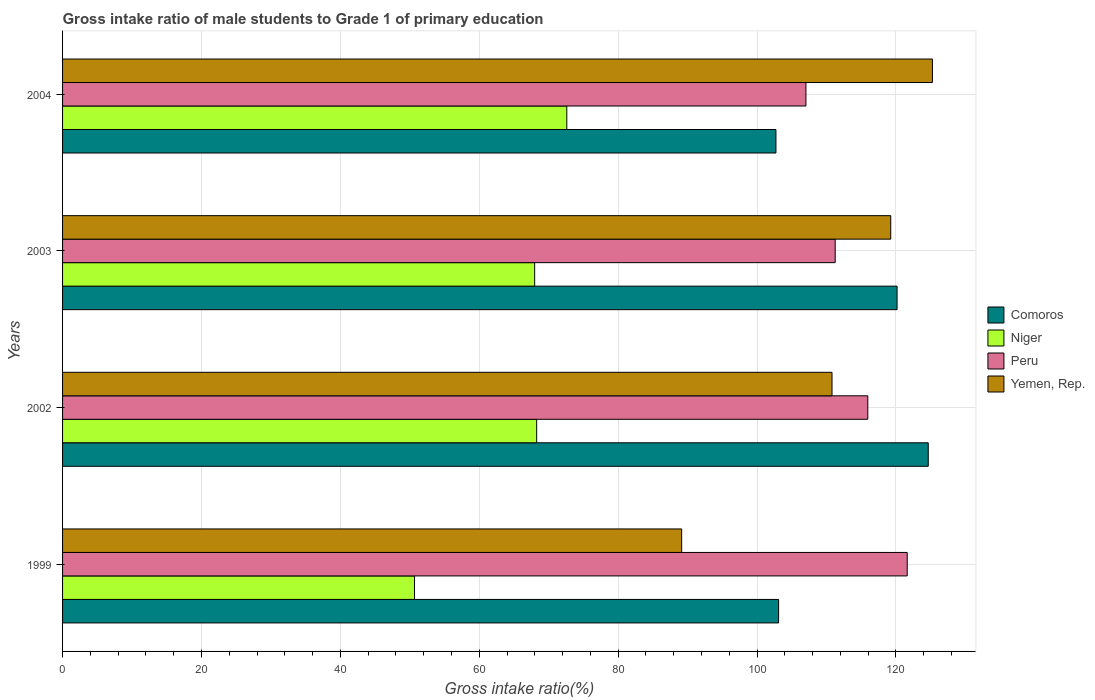How many different coloured bars are there?
Provide a short and direct response. 4. How many groups of bars are there?
Your answer should be compact. 4. Are the number of bars per tick equal to the number of legend labels?
Keep it short and to the point. Yes. Are the number of bars on each tick of the Y-axis equal?
Offer a very short reply. Yes. How many bars are there on the 4th tick from the bottom?
Keep it short and to the point. 4. What is the label of the 1st group of bars from the top?
Make the answer very short. 2004. In how many cases, is the number of bars for a given year not equal to the number of legend labels?
Your response must be concise. 0. What is the gross intake ratio in Comoros in 2002?
Provide a short and direct response. 124.66. Across all years, what is the maximum gross intake ratio in Peru?
Offer a very short reply. 121.63. Across all years, what is the minimum gross intake ratio in Peru?
Provide a succinct answer. 107.05. In which year was the gross intake ratio in Yemen, Rep. minimum?
Make the answer very short. 1999. What is the total gross intake ratio in Yemen, Rep. in the graph?
Your response must be concise. 444.47. What is the difference between the gross intake ratio in Yemen, Rep. in 1999 and that in 2004?
Provide a succinct answer. -36.11. What is the difference between the gross intake ratio in Niger in 1999 and the gross intake ratio in Yemen, Rep. in 2002?
Provide a succinct answer. -60.12. What is the average gross intake ratio in Niger per year?
Make the answer very short. 64.89. In the year 2003, what is the difference between the gross intake ratio in Yemen, Rep. and gross intake ratio in Comoros?
Offer a terse response. -0.91. What is the ratio of the gross intake ratio in Yemen, Rep. in 2003 to that in 2004?
Provide a succinct answer. 0.95. Is the gross intake ratio in Comoros in 2002 less than that in 2003?
Ensure brevity in your answer.  No. What is the difference between the highest and the second highest gross intake ratio in Peru?
Ensure brevity in your answer.  5.68. What is the difference between the highest and the lowest gross intake ratio in Yemen, Rep.?
Offer a very short reply. 36.11. Is the sum of the gross intake ratio in Comoros in 2003 and 2004 greater than the maximum gross intake ratio in Yemen, Rep. across all years?
Offer a terse response. Yes. What does the 2nd bar from the top in 2002 represents?
Your answer should be compact. Peru. What does the 2nd bar from the bottom in 1999 represents?
Give a very brief answer. Niger. Are all the bars in the graph horizontal?
Provide a succinct answer. Yes. How many years are there in the graph?
Keep it short and to the point. 4. What is the difference between two consecutive major ticks on the X-axis?
Keep it short and to the point. 20. Does the graph contain grids?
Ensure brevity in your answer.  Yes. What is the title of the graph?
Keep it short and to the point. Gross intake ratio of male students to Grade 1 of primary education. What is the label or title of the X-axis?
Keep it short and to the point. Gross intake ratio(%). What is the label or title of the Y-axis?
Your answer should be very brief. Years. What is the Gross intake ratio(%) in Comoros in 1999?
Your answer should be compact. 103.11. What is the Gross intake ratio(%) of Niger in 1999?
Make the answer very short. 50.68. What is the Gross intake ratio(%) in Peru in 1999?
Make the answer very short. 121.63. What is the Gross intake ratio(%) of Yemen, Rep. in 1999?
Keep it short and to the point. 89.15. What is the Gross intake ratio(%) in Comoros in 2002?
Give a very brief answer. 124.66. What is the Gross intake ratio(%) in Niger in 2002?
Make the answer very short. 68.27. What is the Gross intake ratio(%) of Peru in 2002?
Give a very brief answer. 115.95. What is the Gross intake ratio(%) in Yemen, Rep. in 2002?
Your answer should be compact. 110.8. What is the Gross intake ratio(%) of Comoros in 2003?
Offer a terse response. 120.17. What is the Gross intake ratio(%) in Niger in 2003?
Provide a succinct answer. 67.98. What is the Gross intake ratio(%) in Peru in 2003?
Your answer should be compact. 111.26. What is the Gross intake ratio(%) of Yemen, Rep. in 2003?
Keep it short and to the point. 119.26. What is the Gross intake ratio(%) of Comoros in 2004?
Offer a very short reply. 102.73. What is the Gross intake ratio(%) in Niger in 2004?
Give a very brief answer. 72.61. What is the Gross intake ratio(%) in Peru in 2004?
Give a very brief answer. 107.05. What is the Gross intake ratio(%) of Yemen, Rep. in 2004?
Provide a succinct answer. 125.26. Across all years, what is the maximum Gross intake ratio(%) of Comoros?
Offer a terse response. 124.66. Across all years, what is the maximum Gross intake ratio(%) of Niger?
Your answer should be compact. 72.61. Across all years, what is the maximum Gross intake ratio(%) of Peru?
Keep it short and to the point. 121.63. Across all years, what is the maximum Gross intake ratio(%) in Yemen, Rep.?
Offer a terse response. 125.26. Across all years, what is the minimum Gross intake ratio(%) in Comoros?
Provide a short and direct response. 102.73. Across all years, what is the minimum Gross intake ratio(%) of Niger?
Make the answer very short. 50.68. Across all years, what is the minimum Gross intake ratio(%) of Peru?
Provide a short and direct response. 107.05. Across all years, what is the minimum Gross intake ratio(%) of Yemen, Rep.?
Your answer should be compact. 89.15. What is the total Gross intake ratio(%) of Comoros in the graph?
Your response must be concise. 450.67. What is the total Gross intake ratio(%) in Niger in the graph?
Keep it short and to the point. 259.54. What is the total Gross intake ratio(%) of Peru in the graph?
Your answer should be very brief. 455.89. What is the total Gross intake ratio(%) in Yemen, Rep. in the graph?
Provide a succinct answer. 444.47. What is the difference between the Gross intake ratio(%) of Comoros in 1999 and that in 2002?
Ensure brevity in your answer.  -21.55. What is the difference between the Gross intake ratio(%) of Niger in 1999 and that in 2002?
Your answer should be compact. -17.59. What is the difference between the Gross intake ratio(%) of Peru in 1999 and that in 2002?
Provide a succinct answer. 5.68. What is the difference between the Gross intake ratio(%) in Yemen, Rep. in 1999 and that in 2002?
Provide a short and direct response. -21.65. What is the difference between the Gross intake ratio(%) of Comoros in 1999 and that in 2003?
Ensure brevity in your answer.  -17.06. What is the difference between the Gross intake ratio(%) of Niger in 1999 and that in 2003?
Your answer should be very brief. -17.3. What is the difference between the Gross intake ratio(%) in Peru in 1999 and that in 2003?
Ensure brevity in your answer.  10.37. What is the difference between the Gross intake ratio(%) in Yemen, Rep. in 1999 and that in 2003?
Your answer should be compact. -30.1. What is the difference between the Gross intake ratio(%) in Comoros in 1999 and that in 2004?
Make the answer very short. 0.38. What is the difference between the Gross intake ratio(%) in Niger in 1999 and that in 2004?
Keep it short and to the point. -21.93. What is the difference between the Gross intake ratio(%) in Peru in 1999 and that in 2004?
Your answer should be compact. 14.58. What is the difference between the Gross intake ratio(%) in Yemen, Rep. in 1999 and that in 2004?
Make the answer very short. -36.11. What is the difference between the Gross intake ratio(%) in Comoros in 2002 and that in 2003?
Your response must be concise. 4.49. What is the difference between the Gross intake ratio(%) in Niger in 2002 and that in 2003?
Provide a succinct answer. 0.29. What is the difference between the Gross intake ratio(%) in Peru in 2002 and that in 2003?
Provide a short and direct response. 4.69. What is the difference between the Gross intake ratio(%) of Yemen, Rep. in 2002 and that in 2003?
Your response must be concise. -8.46. What is the difference between the Gross intake ratio(%) of Comoros in 2002 and that in 2004?
Keep it short and to the point. 21.93. What is the difference between the Gross intake ratio(%) of Niger in 2002 and that in 2004?
Your response must be concise. -4.34. What is the difference between the Gross intake ratio(%) in Peru in 2002 and that in 2004?
Make the answer very short. 8.91. What is the difference between the Gross intake ratio(%) in Yemen, Rep. in 2002 and that in 2004?
Your answer should be compact. -14.46. What is the difference between the Gross intake ratio(%) in Comoros in 2003 and that in 2004?
Offer a very short reply. 17.45. What is the difference between the Gross intake ratio(%) in Niger in 2003 and that in 2004?
Give a very brief answer. -4.63. What is the difference between the Gross intake ratio(%) in Peru in 2003 and that in 2004?
Make the answer very short. 4.21. What is the difference between the Gross intake ratio(%) of Yemen, Rep. in 2003 and that in 2004?
Ensure brevity in your answer.  -6. What is the difference between the Gross intake ratio(%) in Comoros in 1999 and the Gross intake ratio(%) in Niger in 2002?
Provide a succinct answer. 34.84. What is the difference between the Gross intake ratio(%) of Comoros in 1999 and the Gross intake ratio(%) of Peru in 2002?
Your response must be concise. -12.84. What is the difference between the Gross intake ratio(%) of Comoros in 1999 and the Gross intake ratio(%) of Yemen, Rep. in 2002?
Provide a short and direct response. -7.69. What is the difference between the Gross intake ratio(%) in Niger in 1999 and the Gross intake ratio(%) in Peru in 2002?
Provide a short and direct response. -65.28. What is the difference between the Gross intake ratio(%) of Niger in 1999 and the Gross intake ratio(%) of Yemen, Rep. in 2002?
Your answer should be very brief. -60.12. What is the difference between the Gross intake ratio(%) in Peru in 1999 and the Gross intake ratio(%) in Yemen, Rep. in 2002?
Make the answer very short. 10.83. What is the difference between the Gross intake ratio(%) in Comoros in 1999 and the Gross intake ratio(%) in Niger in 2003?
Your response must be concise. 35.13. What is the difference between the Gross intake ratio(%) in Comoros in 1999 and the Gross intake ratio(%) in Peru in 2003?
Offer a very short reply. -8.15. What is the difference between the Gross intake ratio(%) of Comoros in 1999 and the Gross intake ratio(%) of Yemen, Rep. in 2003?
Give a very brief answer. -16.15. What is the difference between the Gross intake ratio(%) in Niger in 1999 and the Gross intake ratio(%) in Peru in 2003?
Your response must be concise. -60.58. What is the difference between the Gross intake ratio(%) in Niger in 1999 and the Gross intake ratio(%) in Yemen, Rep. in 2003?
Your response must be concise. -68.58. What is the difference between the Gross intake ratio(%) in Peru in 1999 and the Gross intake ratio(%) in Yemen, Rep. in 2003?
Offer a terse response. 2.37. What is the difference between the Gross intake ratio(%) in Comoros in 1999 and the Gross intake ratio(%) in Niger in 2004?
Provide a succinct answer. 30.5. What is the difference between the Gross intake ratio(%) in Comoros in 1999 and the Gross intake ratio(%) in Peru in 2004?
Make the answer very short. -3.94. What is the difference between the Gross intake ratio(%) in Comoros in 1999 and the Gross intake ratio(%) in Yemen, Rep. in 2004?
Offer a terse response. -22.15. What is the difference between the Gross intake ratio(%) of Niger in 1999 and the Gross intake ratio(%) of Peru in 2004?
Give a very brief answer. -56.37. What is the difference between the Gross intake ratio(%) of Niger in 1999 and the Gross intake ratio(%) of Yemen, Rep. in 2004?
Provide a succinct answer. -74.58. What is the difference between the Gross intake ratio(%) of Peru in 1999 and the Gross intake ratio(%) of Yemen, Rep. in 2004?
Your response must be concise. -3.63. What is the difference between the Gross intake ratio(%) of Comoros in 2002 and the Gross intake ratio(%) of Niger in 2003?
Your response must be concise. 56.68. What is the difference between the Gross intake ratio(%) in Comoros in 2002 and the Gross intake ratio(%) in Peru in 2003?
Keep it short and to the point. 13.4. What is the difference between the Gross intake ratio(%) in Comoros in 2002 and the Gross intake ratio(%) in Yemen, Rep. in 2003?
Your answer should be compact. 5.4. What is the difference between the Gross intake ratio(%) in Niger in 2002 and the Gross intake ratio(%) in Peru in 2003?
Offer a terse response. -42.99. What is the difference between the Gross intake ratio(%) of Niger in 2002 and the Gross intake ratio(%) of Yemen, Rep. in 2003?
Your answer should be compact. -50.99. What is the difference between the Gross intake ratio(%) in Peru in 2002 and the Gross intake ratio(%) in Yemen, Rep. in 2003?
Keep it short and to the point. -3.3. What is the difference between the Gross intake ratio(%) of Comoros in 2002 and the Gross intake ratio(%) of Niger in 2004?
Offer a very short reply. 52.05. What is the difference between the Gross intake ratio(%) in Comoros in 2002 and the Gross intake ratio(%) in Peru in 2004?
Make the answer very short. 17.61. What is the difference between the Gross intake ratio(%) in Comoros in 2002 and the Gross intake ratio(%) in Yemen, Rep. in 2004?
Make the answer very short. -0.6. What is the difference between the Gross intake ratio(%) of Niger in 2002 and the Gross intake ratio(%) of Peru in 2004?
Give a very brief answer. -38.78. What is the difference between the Gross intake ratio(%) in Niger in 2002 and the Gross intake ratio(%) in Yemen, Rep. in 2004?
Your response must be concise. -56.99. What is the difference between the Gross intake ratio(%) of Peru in 2002 and the Gross intake ratio(%) of Yemen, Rep. in 2004?
Your answer should be compact. -9.31. What is the difference between the Gross intake ratio(%) of Comoros in 2003 and the Gross intake ratio(%) of Niger in 2004?
Offer a terse response. 47.56. What is the difference between the Gross intake ratio(%) in Comoros in 2003 and the Gross intake ratio(%) in Peru in 2004?
Keep it short and to the point. 13.12. What is the difference between the Gross intake ratio(%) in Comoros in 2003 and the Gross intake ratio(%) in Yemen, Rep. in 2004?
Your answer should be very brief. -5.09. What is the difference between the Gross intake ratio(%) in Niger in 2003 and the Gross intake ratio(%) in Peru in 2004?
Provide a short and direct response. -39.07. What is the difference between the Gross intake ratio(%) in Niger in 2003 and the Gross intake ratio(%) in Yemen, Rep. in 2004?
Make the answer very short. -57.28. What is the difference between the Gross intake ratio(%) of Peru in 2003 and the Gross intake ratio(%) of Yemen, Rep. in 2004?
Keep it short and to the point. -14. What is the average Gross intake ratio(%) of Comoros per year?
Your response must be concise. 112.67. What is the average Gross intake ratio(%) in Niger per year?
Your answer should be compact. 64.89. What is the average Gross intake ratio(%) in Peru per year?
Your answer should be very brief. 113.97. What is the average Gross intake ratio(%) in Yemen, Rep. per year?
Ensure brevity in your answer.  111.12. In the year 1999, what is the difference between the Gross intake ratio(%) of Comoros and Gross intake ratio(%) of Niger?
Offer a very short reply. 52.43. In the year 1999, what is the difference between the Gross intake ratio(%) in Comoros and Gross intake ratio(%) in Peru?
Your answer should be compact. -18.52. In the year 1999, what is the difference between the Gross intake ratio(%) in Comoros and Gross intake ratio(%) in Yemen, Rep.?
Offer a terse response. 13.96. In the year 1999, what is the difference between the Gross intake ratio(%) in Niger and Gross intake ratio(%) in Peru?
Your answer should be very brief. -70.95. In the year 1999, what is the difference between the Gross intake ratio(%) of Niger and Gross intake ratio(%) of Yemen, Rep.?
Offer a terse response. -38.48. In the year 1999, what is the difference between the Gross intake ratio(%) of Peru and Gross intake ratio(%) of Yemen, Rep.?
Your response must be concise. 32.48. In the year 2002, what is the difference between the Gross intake ratio(%) of Comoros and Gross intake ratio(%) of Niger?
Your answer should be very brief. 56.39. In the year 2002, what is the difference between the Gross intake ratio(%) of Comoros and Gross intake ratio(%) of Peru?
Your response must be concise. 8.71. In the year 2002, what is the difference between the Gross intake ratio(%) in Comoros and Gross intake ratio(%) in Yemen, Rep.?
Provide a short and direct response. 13.86. In the year 2002, what is the difference between the Gross intake ratio(%) of Niger and Gross intake ratio(%) of Peru?
Provide a succinct answer. -47.68. In the year 2002, what is the difference between the Gross intake ratio(%) of Niger and Gross intake ratio(%) of Yemen, Rep.?
Ensure brevity in your answer.  -42.53. In the year 2002, what is the difference between the Gross intake ratio(%) of Peru and Gross intake ratio(%) of Yemen, Rep.?
Give a very brief answer. 5.15. In the year 2003, what is the difference between the Gross intake ratio(%) in Comoros and Gross intake ratio(%) in Niger?
Ensure brevity in your answer.  52.19. In the year 2003, what is the difference between the Gross intake ratio(%) in Comoros and Gross intake ratio(%) in Peru?
Keep it short and to the point. 8.91. In the year 2003, what is the difference between the Gross intake ratio(%) of Comoros and Gross intake ratio(%) of Yemen, Rep.?
Your response must be concise. 0.91. In the year 2003, what is the difference between the Gross intake ratio(%) of Niger and Gross intake ratio(%) of Peru?
Make the answer very short. -43.28. In the year 2003, what is the difference between the Gross intake ratio(%) in Niger and Gross intake ratio(%) in Yemen, Rep.?
Give a very brief answer. -51.28. In the year 2003, what is the difference between the Gross intake ratio(%) of Peru and Gross intake ratio(%) of Yemen, Rep.?
Ensure brevity in your answer.  -8. In the year 2004, what is the difference between the Gross intake ratio(%) in Comoros and Gross intake ratio(%) in Niger?
Your response must be concise. 30.12. In the year 2004, what is the difference between the Gross intake ratio(%) in Comoros and Gross intake ratio(%) in Peru?
Offer a very short reply. -4.32. In the year 2004, what is the difference between the Gross intake ratio(%) of Comoros and Gross intake ratio(%) of Yemen, Rep.?
Offer a very short reply. -22.53. In the year 2004, what is the difference between the Gross intake ratio(%) of Niger and Gross intake ratio(%) of Peru?
Your response must be concise. -34.44. In the year 2004, what is the difference between the Gross intake ratio(%) in Niger and Gross intake ratio(%) in Yemen, Rep.?
Provide a succinct answer. -52.65. In the year 2004, what is the difference between the Gross intake ratio(%) in Peru and Gross intake ratio(%) in Yemen, Rep.?
Ensure brevity in your answer.  -18.21. What is the ratio of the Gross intake ratio(%) in Comoros in 1999 to that in 2002?
Provide a succinct answer. 0.83. What is the ratio of the Gross intake ratio(%) of Niger in 1999 to that in 2002?
Ensure brevity in your answer.  0.74. What is the ratio of the Gross intake ratio(%) in Peru in 1999 to that in 2002?
Make the answer very short. 1.05. What is the ratio of the Gross intake ratio(%) of Yemen, Rep. in 1999 to that in 2002?
Ensure brevity in your answer.  0.8. What is the ratio of the Gross intake ratio(%) in Comoros in 1999 to that in 2003?
Ensure brevity in your answer.  0.86. What is the ratio of the Gross intake ratio(%) of Niger in 1999 to that in 2003?
Offer a very short reply. 0.75. What is the ratio of the Gross intake ratio(%) of Peru in 1999 to that in 2003?
Keep it short and to the point. 1.09. What is the ratio of the Gross intake ratio(%) of Yemen, Rep. in 1999 to that in 2003?
Give a very brief answer. 0.75. What is the ratio of the Gross intake ratio(%) in Niger in 1999 to that in 2004?
Provide a short and direct response. 0.7. What is the ratio of the Gross intake ratio(%) in Peru in 1999 to that in 2004?
Keep it short and to the point. 1.14. What is the ratio of the Gross intake ratio(%) in Yemen, Rep. in 1999 to that in 2004?
Your answer should be compact. 0.71. What is the ratio of the Gross intake ratio(%) in Comoros in 2002 to that in 2003?
Provide a short and direct response. 1.04. What is the ratio of the Gross intake ratio(%) in Peru in 2002 to that in 2003?
Give a very brief answer. 1.04. What is the ratio of the Gross intake ratio(%) of Yemen, Rep. in 2002 to that in 2003?
Ensure brevity in your answer.  0.93. What is the ratio of the Gross intake ratio(%) of Comoros in 2002 to that in 2004?
Provide a succinct answer. 1.21. What is the ratio of the Gross intake ratio(%) in Niger in 2002 to that in 2004?
Offer a terse response. 0.94. What is the ratio of the Gross intake ratio(%) in Peru in 2002 to that in 2004?
Your answer should be compact. 1.08. What is the ratio of the Gross intake ratio(%) in Yemen, Rep. in 2002 to that in 2004?
Keep it short and to the point. 0.88. What is the ratio of the Gross intake ratio(%) of Comoros in 2003 to that in 2004?
Give a very brief answer. 1.17. What is the ratio of the Gross intake ratio(%) in Niger in 2003 to that in 2004?
Provide a succinct answer. 0.94. What is the ratio of the Gross intake ratio(%) in Peru in 2003 to that in 2004?
Your answer should be very brief. 1.04. What is the ratio of the Gross intake ratio(%) of Yemen, Rep. in 2003 to that in 2004?
Ensure brevity in your answer.  0.95. What is the difference between the highest and the second highest Gross intake ratio(%) of Comoros?
Your answer should be very brief. 4.49. What is the difference between the highest and the second highest Gross intake ratio(%) in Niger?
Offer a very short reply. 4.34. What is the difference between the highest and the second highest Gross intake ratio(%) of Peru?
Your answer should be very brief. 5.68. What is the difference between the highest and the second highest Gross intake ratio(%) of Yemen, Rep.?
Your answer should be very brief. 6. What is the difference between the highest and the lowest Gross intake ratio(%) of Comoros?
Offer a very short reply. 21.93. What is the difference between the highest and the lowest Gross intake ratio(%) in Niger?
Offer a terse response. 21.93. What is the difference between the highest and the lowest Gross intake ratio(%) in Peru?
Your answer should be compact. 14.58. What is the difference between the highest and the lowest Gross intake ratio(%) in Yemen, Rep.?
Your answer should be compact. 36.11. 